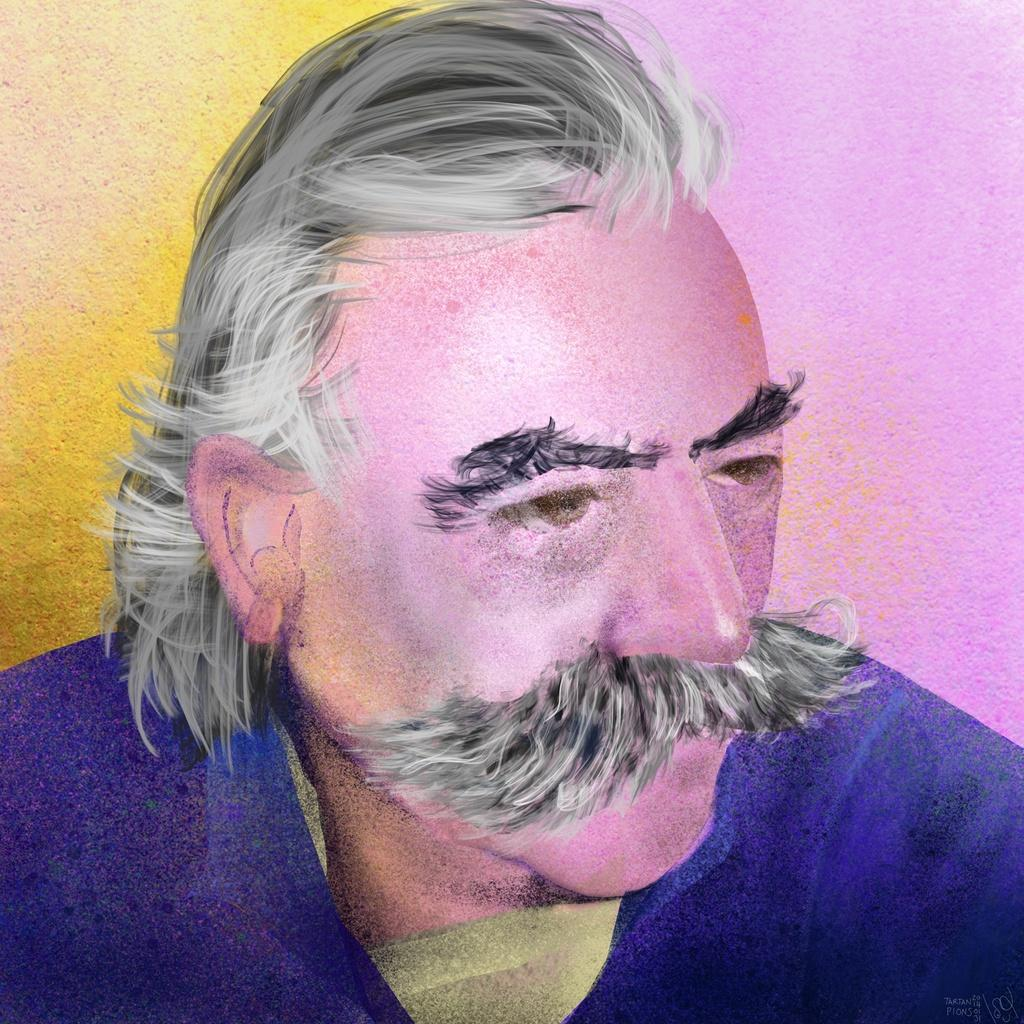What is the main subject of the image? There is a painting in the image. What is depicted in the painting? The painting features a man. What type of polish is being applied to the road in the image? There is no road or polish present in the image; it features a painting of a man. How many rail tracks are visible in the image? There are no rail tracks present in the image; it features a painting of a man. 